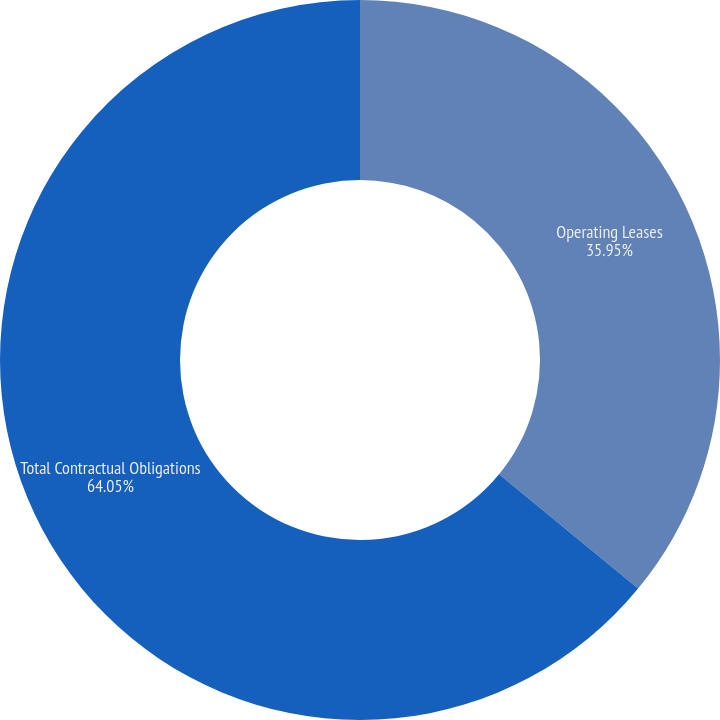Convert chart. <chart><loc_0><loc_0><loc_500><loc_500><pie_chart><fcel>Operating Leases<fcel>Total Contractual Obligations<nl><fcel>35.95%<fcel>64.05%<nl></chart> 